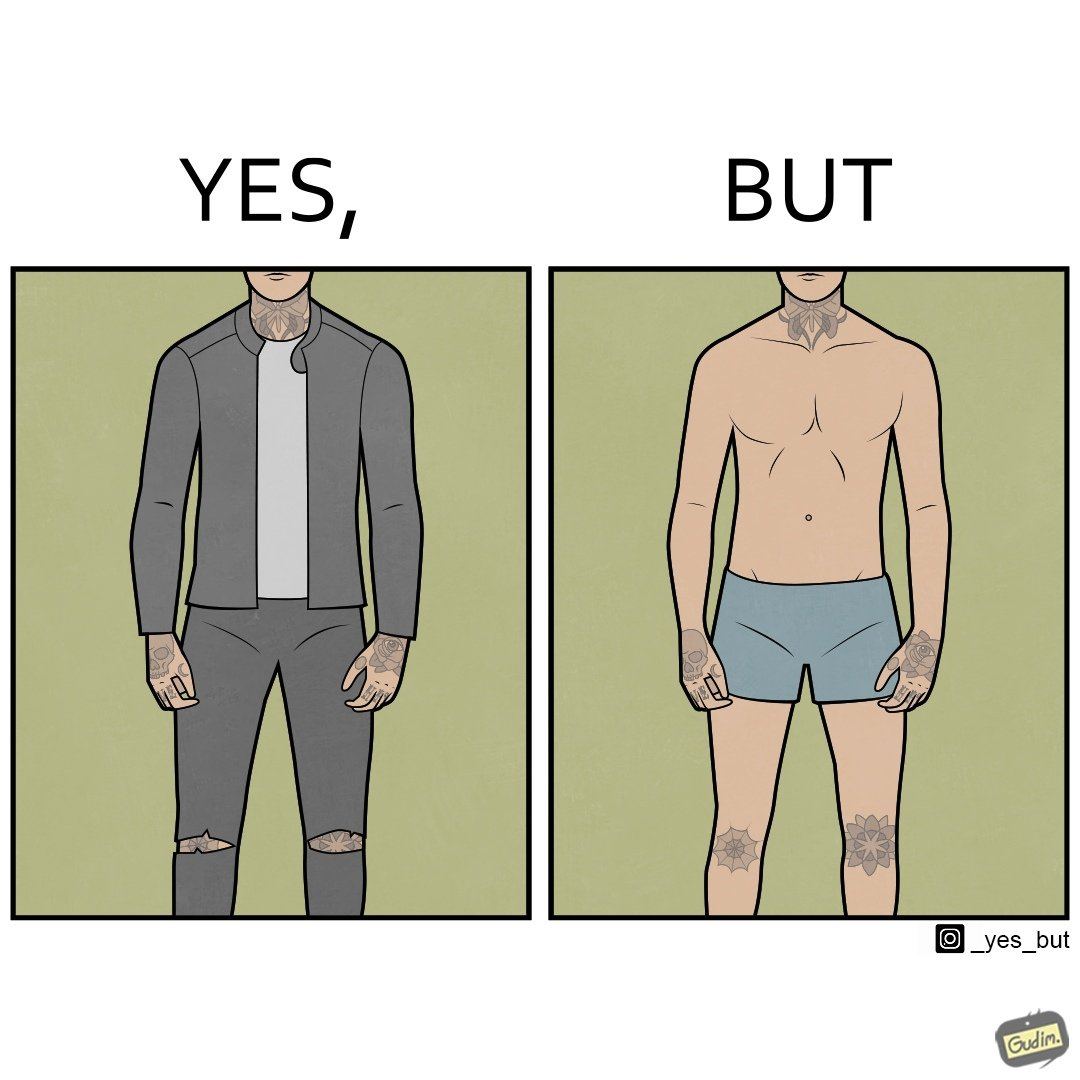Describe the content of this image. The images are funny since it shows a man with tattoos on his exposed body parts in normal clothing gives the illusion that he has tattoos all over his body, but in reality, he has tattoos only on those few parts. 